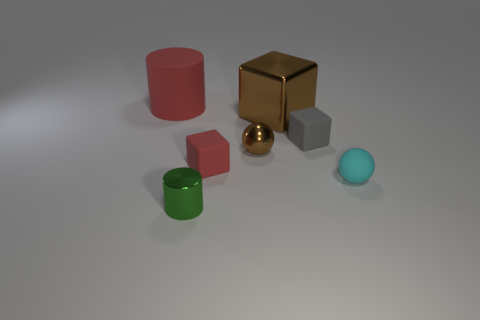Subtract all tiny matte cubes. How many cubes are left? 1 Subtract all red cubes. How many cubes are left? 2 Subtract all cylinders. How many objects are left? 5 Subtract 1 balls. How many balls are left? 1 Subtract all blue blocks. How many green cylinders are left? 1 Subtract all small gray rubber cubes. Subtract all tiny brown cylinders. How many objects are left? 6 Add 1 small metal balls. How many small metal balls are left? 2 Add 5 matte objects. How many matte objects exist? 9 Add 2 big red matte cylinders. How many objects exist? 9 Subtract 0 purple cylinders. How many objects are left? 7 